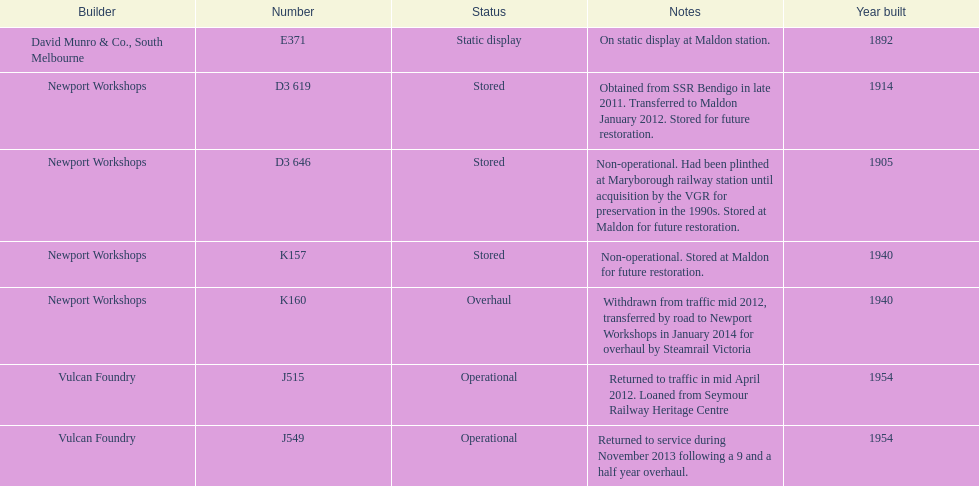How many of the locomotives were built before 1940? 3. 